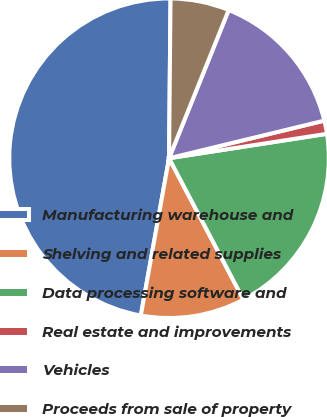Convert chart. <chart><loc_0><loc_0><loc_500><loc_500><pie_chart><fcel>Manufacturing warehouse and<fcel>Shelving and related supplies<fcel>Data processing software and<fcel>Real estate and improvements<fcel>Vehicles<fcel>Proceeds from sale of property<nl><fcel>47.32%<fcel>10.54%<fcel>19.73%<fcel>1.34%<fcel>15.13%<fcel>5.94%<nl></chart> 